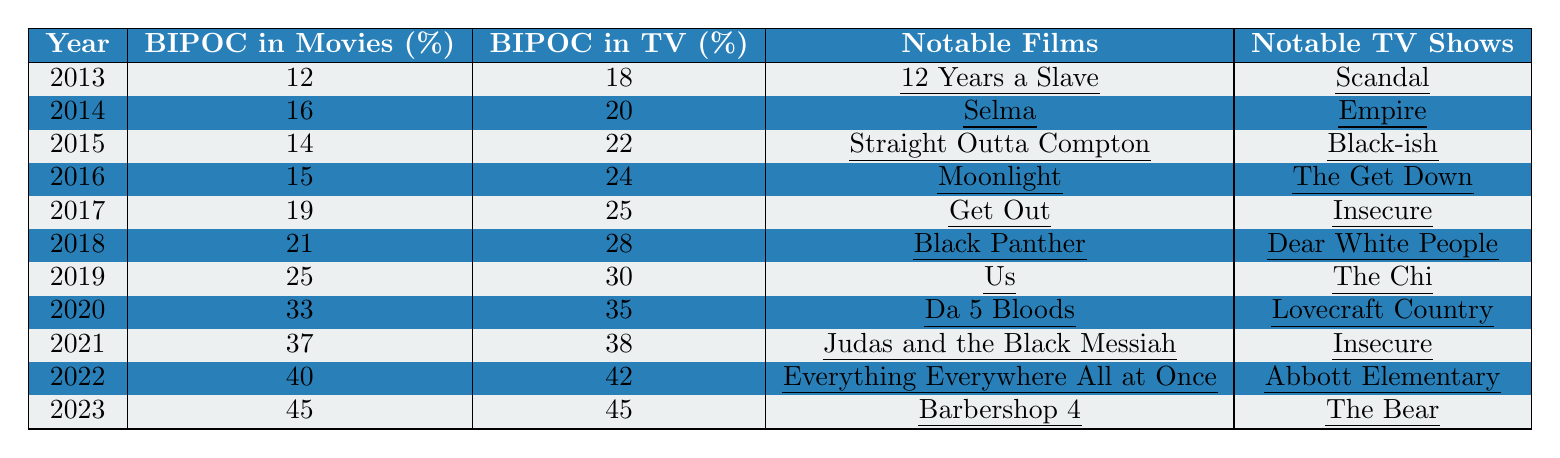What was the percentage of BIPOC individuals in movies in 2015? Referring to the table, in 2015, the percentage of BIPOC individuals in movies is explicitly listed as 14%.
Answer: 14% What notable film was released in 2019? In 2019, one of the notable films listed is "Us".
Answer: Us Which year saw the highest percentage of BIPOC representation in TV shows? Looking at the table, 2023 shows the highest percentage of BIPOC representation in TV shows at 45%.
Answer: 2023 What is the difference in the percentage of BIPOC in movies between 2014 and 2022? The percentage in 2014 is 16% and in 2022 it is 40%. The difference is 40% - 16% = 24%.
Answer: 24% How many notable films are listed for the year 2021? The year 2021 has two notable films listed: "Judas and the Black Messiah" and "The Harder They Fall".
Answer: 2 Was there an increase in BIPOC representation in movies from 2016 to 2017? In 2016, the percentage was 15% and in 2017, it rose to 19%, indicating an increase.
Answer: Yes What is the average percentage of BIPOC representation in movies from 2013 to 2020? Add the percentages from 2013 to 2020: (12 + 16 + 14 + 15 + 19 + 21 + 25 + 33) = 155. There are 8 years, so the average is 155 / 8 = 19.375%, rounded to 19.4%.
Answer: 19.4% Did the percentage of BIPOC representation in TV shows surpass the percentage in movies in 2022? In 2022, the percentage of BIPOC in TV shows is 42% and in movies is 40%, so it did surpass it.
Answer: Yes In which year did BIPOC representation in movies first exceed 30%? The percentage first exceeded 30% in 2020, where it reached 33%.
Answer: 2020 What notable TV show was associated with BIPOC representation in movies in 2018? In 2018, "Dear White People" was the notable TV show listed alongside the percentage of 21% in movies.
Answer: Dear White People 